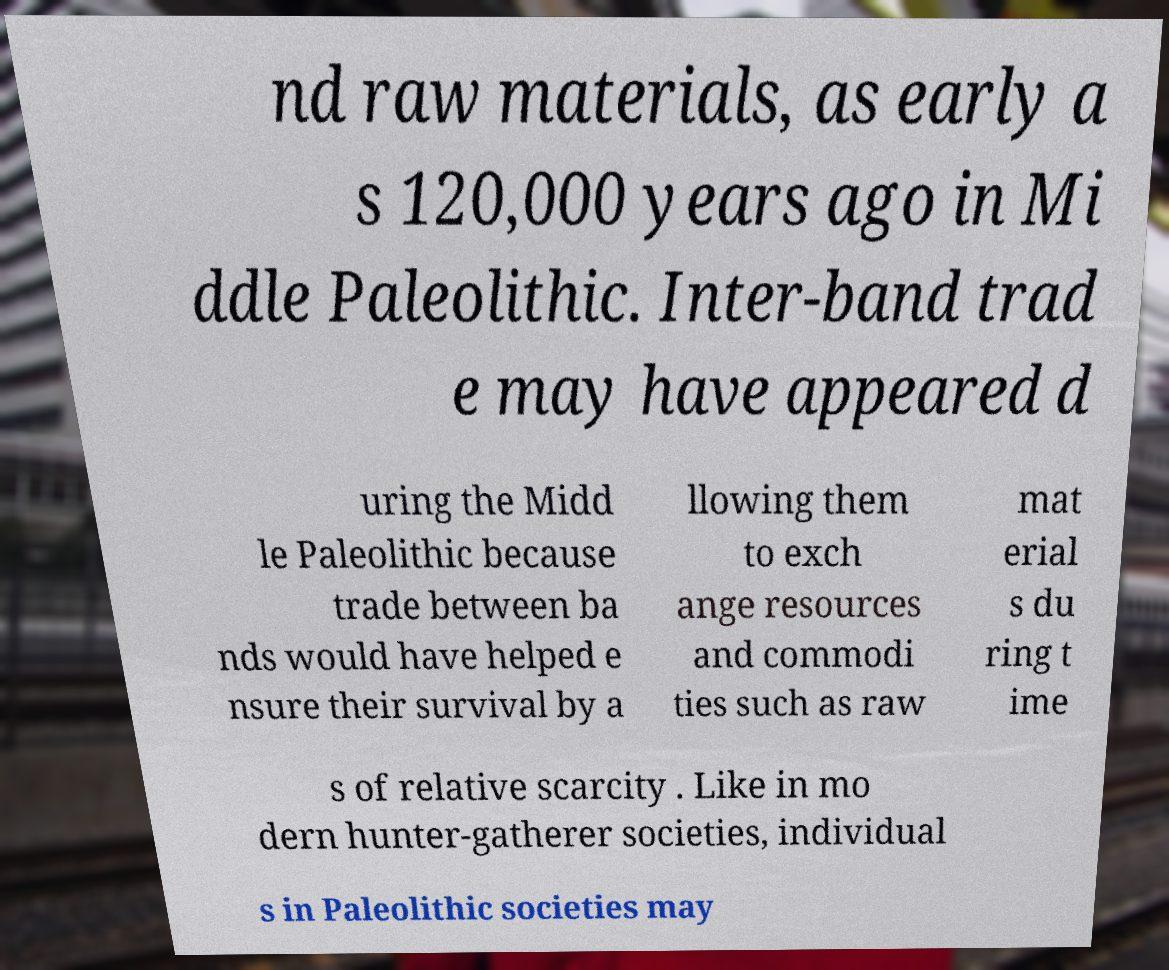Could you assist in decoding the text presented in this image and type it out clearly? nd raw materials, as early a s 120,000 years ago in Mi ddle Paleolithic. Inter-band trad e may have appeared d uring the Midd le Paleolithic because trade between ba nds would have helped e nsure their survival by a llowing them to exch ange resources and commodi ties such as raw mat erial s du ring t ime s of relative scarcity . Like in mo dern hunter-gatherer societies, individual s in Paleolithic societies may 